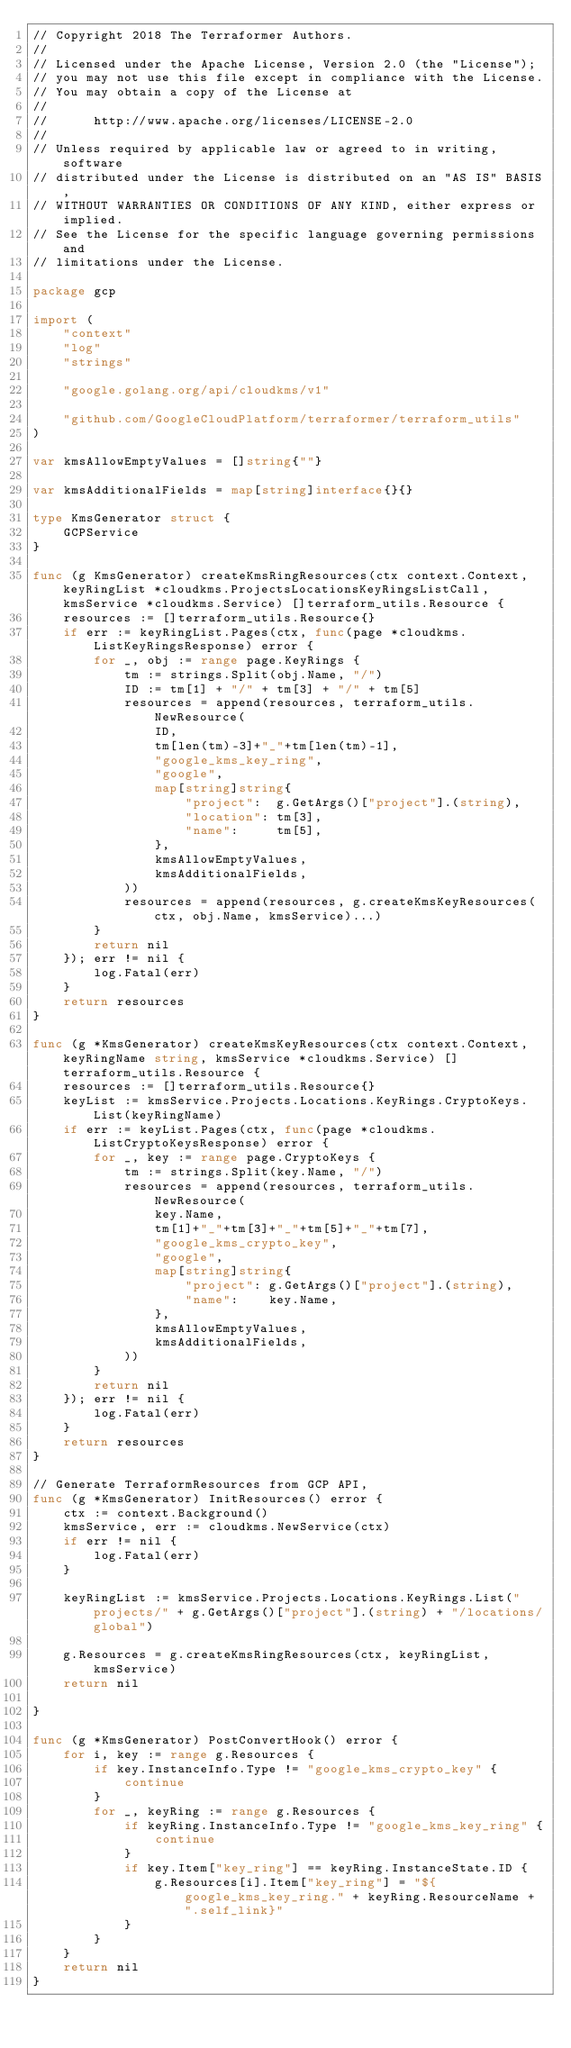Convert code to text. <code><loc_0><loc_0><loc_500><loc_500><_Go_>// Copyright 2018 The Terraformer Authors.
//
// Licensed under the Apache License, Version 2.0 (the "License");
// you may not use this file except in compliance with the License.
// You may obtain a copy of the License at
//
//      http://www.apache.org/licenses/LICENSE-2.0
//
// Unless required by applicable law or agreed to in writing, software
// distributed under the License is distributed on an "AS IS" BASIS,
// WITHOUT WARRANTIES OR CONDITIONS OF ANY KIND, either express or implied.
// See the License for the specific language governing permissions and
// limitations under the License.

package gcp

import (
	"context"
	"log"
	"strings"

	"google.golang.org/api/cloudkms/v1"

	"github.com/GoogleCloudPlatform/terraformer/terraform_utils"
)

var kmsAllowEmptyValues = []string{""}

var kmsAdditionalFields = map[string]interface{}{}

type KmsGenerator struct {
	GCPService
}

func (g KmsGenerator) createKmsRingResources(ctx context.Context, keyRingList *cloudkms.ProjectsLocationsKeyRingsListCall, kmsService *cloudkms.Service) []terraform_utils.Resource {
	resources := []terraform_utils.Resource{}
	if err := keyRingList.Pages(ctx, func(page *cloudkms.ListKeyRingsResponse) error {
		for _, obj := range page.KeyRings {
			tm := strings.Split(obj.Name, "/")
			ID := tm[1] + "/" + tm[3] + "/" + tm[5]
			resources = append(resources, terraform_utils.NewResource(
				ID,
				tm[len(tm)-3]+"_"+tm[len(tm)-1],
				"google_kms_key_ring",
				"google",
				map[string]string{
					"project":  g.GetArgs()["project"].(string),
					"location": tm[3],
					"name":     tm[5],
				},
				kmsAllowEmptyValues,
				kmsAdditionalFields,
			))
			resources = append(resources, g.createKmsKeyResources(ctx, obj.Name, kmsService)...)
		}
		return nil
	}); err != nil {
		log.Fatal(err)
	}
	return resources
}

func (g *KmsGenerator) createKmsKeyResources(ctx context.Context, keyRingName string, kmsService *cloudkms.Service) []terraform_utils.Resource {
	resources := []terraform_utils.Resource{}
	keyList := kmsService.Projects.Locations.KeyRings.CryptoKeys.List(keyRingName)
	if err := keyList.Pages(ctx, func(page *cloudkms.ListCryptoKeysResponse) error {
		for _, key := range page.CryptoKeys {
			tm := strings.Split(key.Name, "/")
			resources = append(resources, terraform_utils.NewResource(
				key.Name,
				tm[1]+"_"+tm[3]+"_"+tm[5]+"_"+tm[7],
				"google_kms_crypto_key",
				"google",
				map[string]string{
					"project": g.GetArgs()["project"].(string),
					"name":    key.Name,
				},
				kmsAllowEmptyValues,
				kmsAdditionalFields,
			))
		}
		return nil
	}); err != nil {
		log.Fatal(err)
	}
	return resources
}

// Generate TerraformResources from GCP API,
func (g *KmsGenerator) InitResources() error {
	ctx := context.Background()
	kmsService, err := cloudkms.NewService(ctx)
	if err != nil {
		log.Fatal(err)
	}

	keyRingList := kmsService.Projects.Locations.KeyRings.List("projects/" + g.GetArgs()["project"].(string) + "/locations/global")

	g.Resources = g.createKmsRingResources(ctx, keyRingList, kmsService)
	return nil

}

func (g *KmsGenerator) PostConvertHook() error {
	for i, key := range g.Resources {
		if key.InstanceInfo.Type != "google_kms_crypto_key" {
			continue
		}
		for _, keyRing := range g.Resources {
			if keyRing.InstanceInfo.Type != "google_kms_key_ring" {
				continue
			}
			if key.Item["key_ring"] == keyRing.InstanceState.ID {
				g.Resources[i].Item["key_ring"] = "${google_kms_key_ring." + keyRing.ResourceName + ".self_link}"
			}
		}
	}
	return nil
}
</code> 